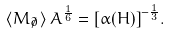Convert formula to latex. <formula><loc_0><loc_0><loc_500><loc_500>\left < M _ { \not \partial } \right > A ^ { \frac { 1 } { 6 } } = { \left [ \alpha ( H ) \right ] } ^ { - \frac { 1 } { 3 } } .</formula> 